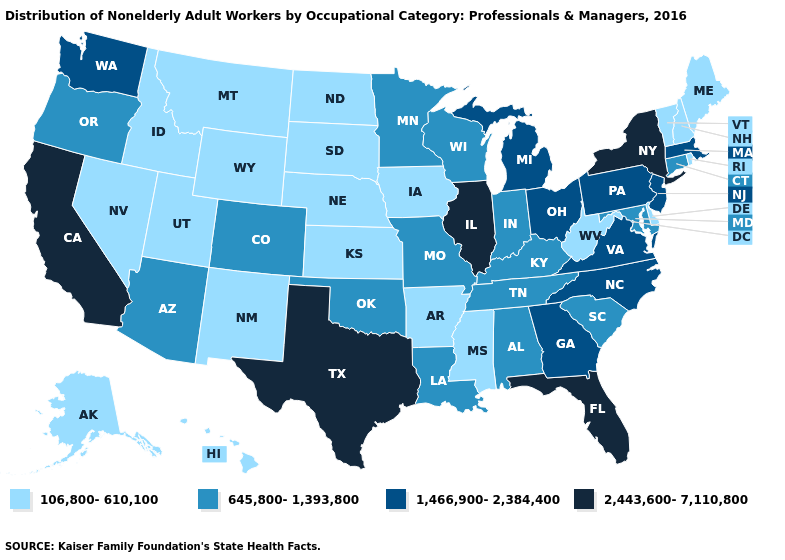Name the states that have a value in the range 2,443,600-7,110,800?
Keep it brief. California, Florida, Illinois, New York, Texas. What is the value of Texas?
Give a very brief answer. 2,443,600-7,110,800. Does Washington have a lower value than Kentucky?
Answer briefly. No. Among the states that border Minnesota , does Iowa have the lowest value?
Keep it brief. Yes. Name the states that have a value in the range 645,800-1,393,800?
Write a very short answer. Alabama, Arizona, Colorado, Connecticut, Indiana, Kentucky, Louisiana, Maryland, Minnesota, Missouri, Oklahoma, Oregon, South Carolina, Tennessee, Wisconsin. What is the highest value in the West ?
Short answer required. 2,443,600-7,110,800. Does the first symbol in the legend represent the smallest category?
Give a very brief answer. Yes. What is the value of Hawaii?
Write a very short answer. 106,800-610,100. Does the map have missing data?
Keep it brief. No. Name the states that have a value in the range 2,443,600-7,110,800?
Quick response, please. California, Florida, Illinois, New York, Texas. Does the map have missing data?
Give a very brief answer. No. Which states hav the highest value in the South?
Short answer required. Florida, Texas. Does the first symbol in the legend represent the smallest category?
Short answer required. Yes. Name the states that have a value in the range 645,800-1,393,800?
Answer briefly. Alabama, Arizona, Colorado, Connecticut, Indiana, Kentucky, Louisiana, Maryland, Minnesota, Missouri, Oklahoma, Oregon, South Carolina, Tennessee, Wisconsin. Name the states that have a value in the range 1,466,900-2,384,400?
Answer briefly. Georgia, Massachusetts, Michigan, New Jersey, North Carolina, Ohio, Pennsylvania, Virginia, Washington. 